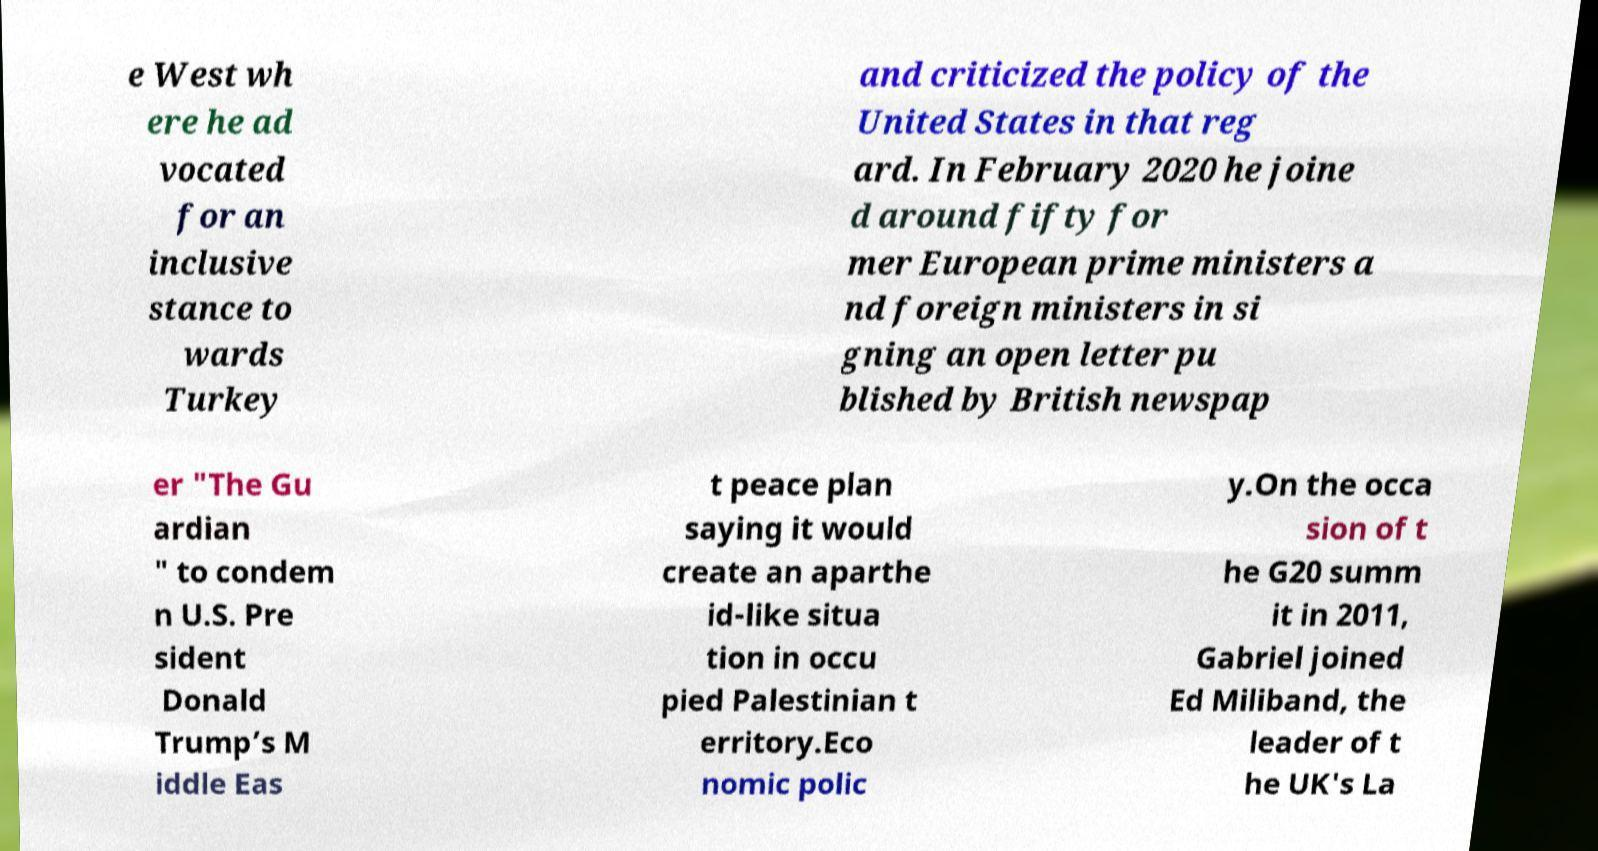There's text embedded in this image that I need extracted. Can you transcribe it verbatim? e West wh ere he ad vocated for an inclusive stance to wards Turkey and criticized the policy of the United States in that reg ard. In February 2020 he joine d around fifty for mer European prime ministers a nd foreign ministers in si gning an open letter pu blished by British newspap er "The Gu ardian " to condem n U.S. Pre sident Donald Trump’s M iddle Eas t peace plan saying it would create an aparthe id-like situa tion in occu pied Palestinian t erritory.Eco nomic polic y.On the occa sion of t he G20 summ it in 2011, Gabriel joined Ed Miliband, the leader of t he UK's La 